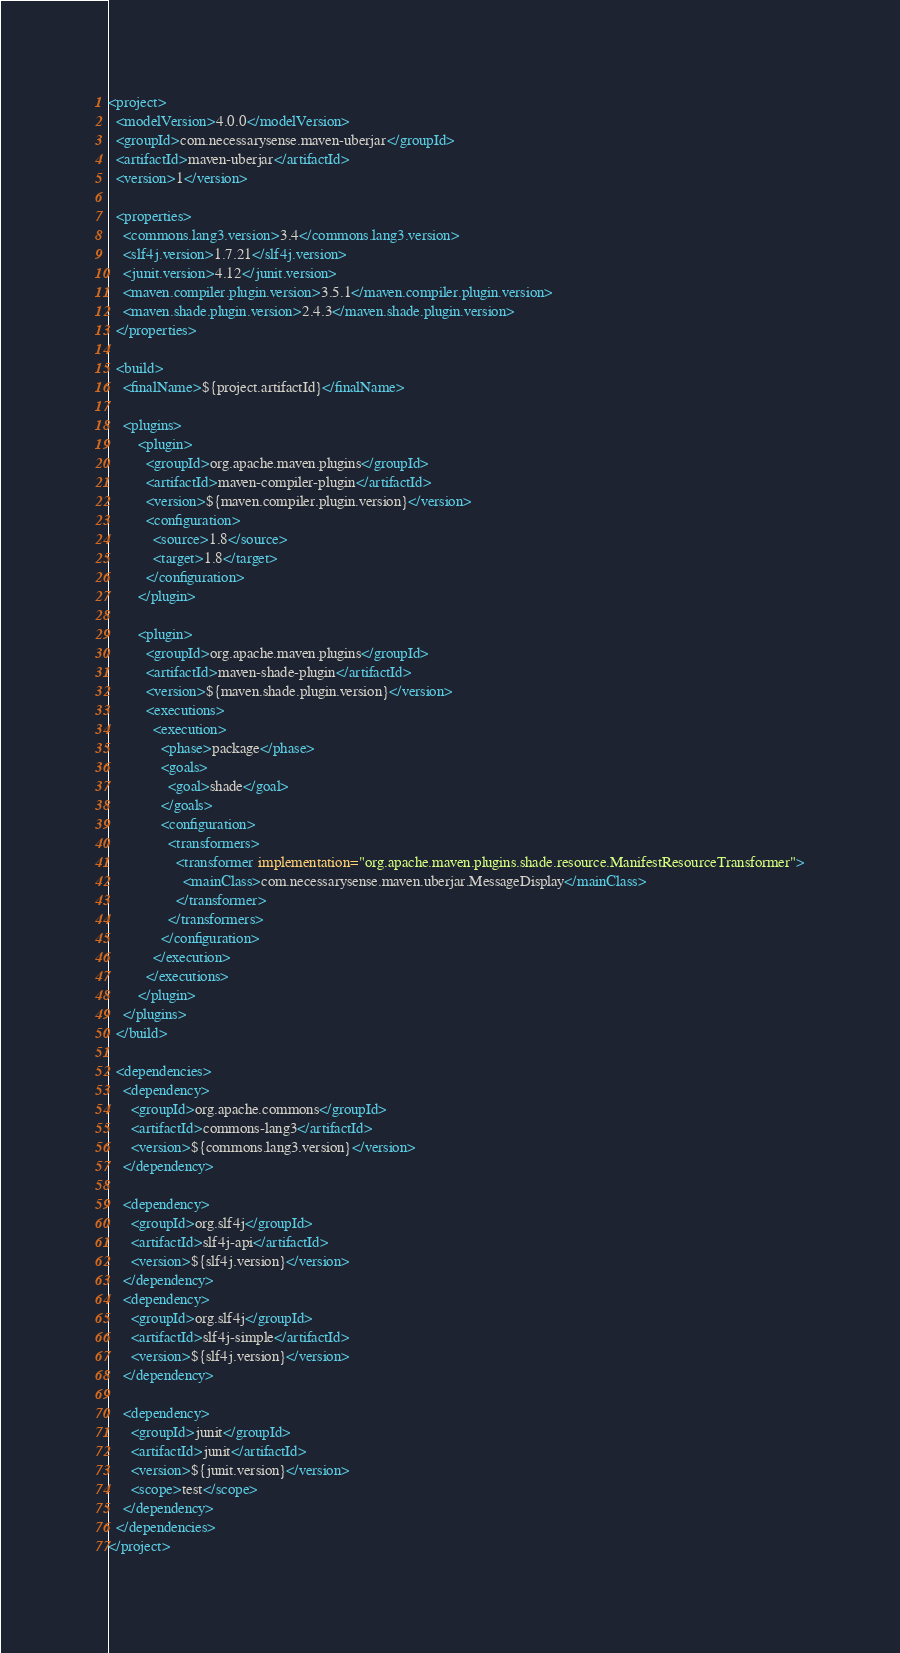<code> <loc_0><loc_0><loc_500><loc_500><_XML_><project>
  <modelVersion>4.0.0</modelVersion>
  <groupId>com.necessarysense.maven-uberjar</groupId>
  <artifactId>maven-uberjar</artifactId>
  <version>1</version>

  <properties>
	<commons.lang3.version>3.4</commons.lang3.version>
	<slf4j.version>1.7.21</slf4j.version>
	<junit.version>4.12</junit.version>
	<maven.compiler.plugin.version>3.5.1</maven.compiler.plugin.version>
	<maven.shade.plugin.version>2.4.3</maven.shade.plugin.version>
  </properties>

  <build>
	<finalName>${project.artifactId}</finalName>
	
	<plugins>
		<plugin>
		  <groupId>org.apache.maven.plugins</groupId>
		  <artifactId>maven-compiler-plugin</artifactId>
		  <version>${maven.compiler.plugin.version}</version>
          <configuration>
            <source>1.8</source>
            <target>1.8</target>
          </configuration>
		</plugin>
		
	  	<plugin>
		  <groupId>org.apache.maven.plugins</groupId>
		  <artifactId>maven-shade-plugin</artifactId>
		  <version>${maven.shade.plugin.version}</version>
		  <executions>
			<execution>
			  <phase>package</phase>
			  <goals>
				<goal>shade</goal>
			  </goals>
			  <configuration>
				<transformers>
				  <transformer implementation="org.apache.maven.plugins.shade.resource.ManifestResourceTransformer">
					<mainClass>com.necessarysense.maven.uberjar.MessageDisplay</mainClass>
				  </transformer>
				</transformers>
			  </configuration>
			</execution>
		  </executions>
		</plugin>
	</plugins>	
  </build>

  <dependencies>
	<dependency>
	  <groupId>org.apache.commons</groupId>
	  <artifactId>commons-lang3</artifactId>
	  <version>${commons.lang3.version}</version>
	</dependency>
	
	<dependency>
	  <groupId>org.slf4j</groupId>
	  <artifactId>slf4j-api</artifactId>
	  <version>${slf4j.version}</version>
	</dependency>
	<dependency>
	  <groupId>org.slf4j</groupId>
	  <artifactId>slf4j-simple</artifactId>
	  <version>${slf4j.version}</version>
	</dependency>
	
	<dependency>
	  <groupId>junit</groupId>
	  <artifactId>junit</artifactId>
	  <version>${junit.version}</version>
	  <scope>test</scope>
	</dependency>
  </dependencies>	
</project></code> 